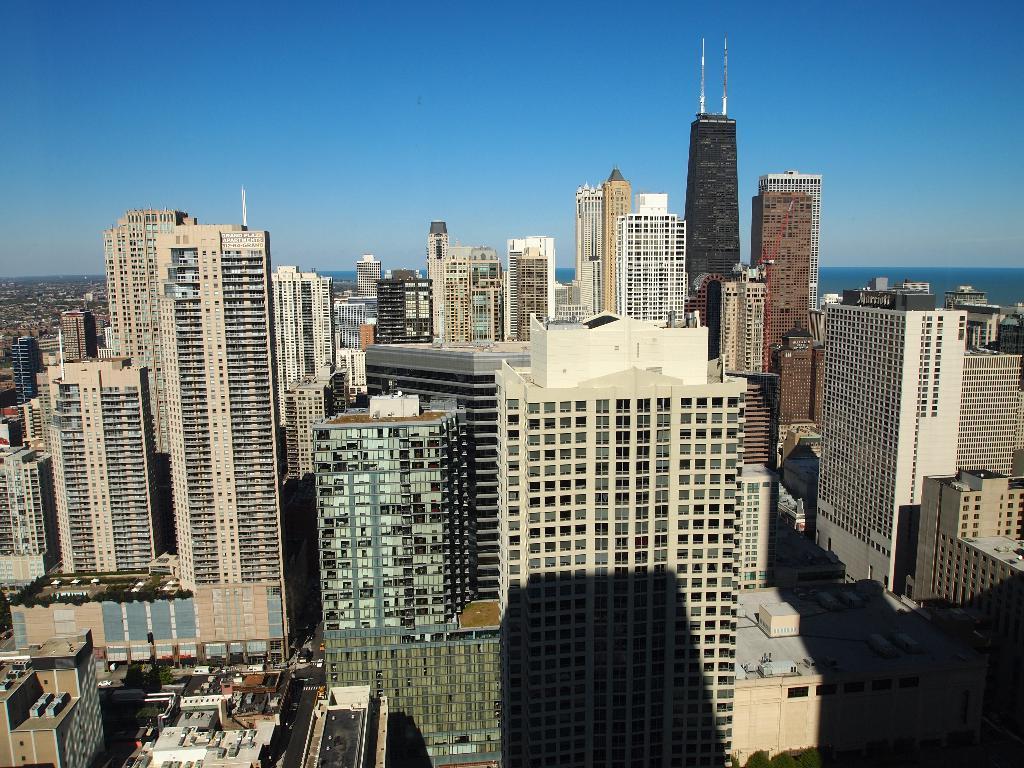How would you summarize this image in a sentence or two? In this image we can see many buildings and skyscrapers. There are many plants at the left side of the image. There are few vehicles on the road at the bottom of the image. We can see the sky in the image. 